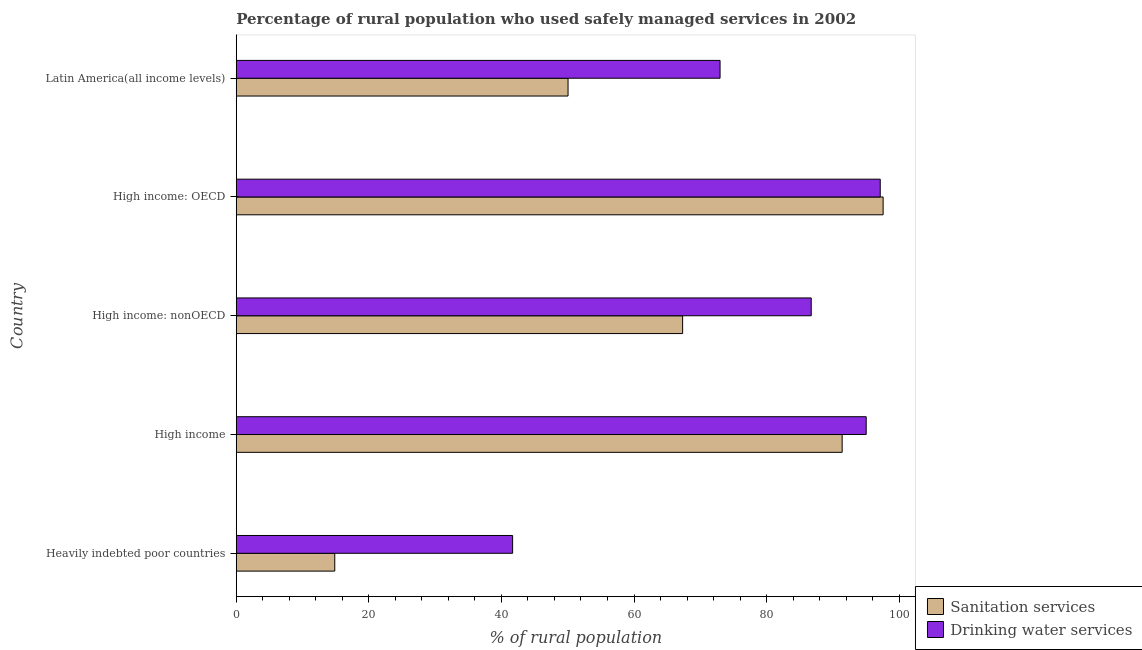How many different coloured bars are there?
Provide a short and direct response. 2. How many groups of bars are there?
Provide a succinct answer. 5. How many bars are there on the 5th tick from the top?
Your answer should be compact. 2. In how many cases, is the number of bars for a given country not equal to the number of legend labels?
Your response must be concise. 0. What is the percentage of rural population who used drinking water services in High income: nonOECD?
Your answer should be very brief. 86.73. Across all countries, what is the maximum percentage of rural population who used sanitation services?
Provide a short and direct response. 97.58. Across all countries, what is the minimum percentage of rural population who used drinking water services?
Provide a succinct answer. 41.69. In which country was the percentage of rural population who used drinking water services maximum?
Keep it short and to the point. High income: OECD. In which country was the percentage of rural population who used sanitation services minimum?
Your response must be concise. Heavily indebted poor countries. What is the total percentage of rural population who used sanitation services in the graph?
Provide a short and direct response. 321.23. What is the difference between the percentage of rural population who used drinking water services in High income and that in High income: OECD?
Provide a succinct answer. -2.12. What is the difference between the percentage of rural population who used sanitation services in High income and the percentage of rural population who used drinking water services in Latin America(all income levels)?
Keep it short and to the point. 18.42. What is the average percentage of rural population who used drinking water services per country?
Offer a very short reply. 78.72. What is the difference between the percentage of rural population who used drinking water services and percentage of rural population who used sanitation services in Heavily indebted poor countries?
Make the answer very short. 26.83. What is the ratio of the percentage of rural population who used drinking water services in High income: OECD to that in Latin America(all income levels)?
Your response must be concise. 1.33. What is the difference between the highest and the second highest percentage of rural population who used drinking water services?
Your response must be concise. 2.12. What is the difference between the highest and the lowest percentage of rural population who used drinking water services?
Keep it short and to the point. 55.45. What does the 2nd bar from the top in High income: nonOECD represents?
Offer a terse response. Sanitation services. What does the 2nd bar from the bottom in High income represents?
Your response must be concise. Drinking water services. How many bars are there?
Offer a very short reply. 10. Are all the bars in the graph horizontal?
Make the answer very short. Yes. What is the difference between two consecutive major ticks on the X-axis?
Offer a terse response. 20. Does the graph contain grids?
Offer a terse response. No. Where does the legend appear in the graph?
Your answer should be compact. Bottom right. How are the legend labels stacked?
Offer a very short reply. Vertical. What is the title of the graph?
Provide a short and direct response. Percentage of rural population who used safely managed services in 2002. What is the label or title of the X-axis?
Keep it short and to the point. % of rural population. What is the label or title of the Y-axis?
Provide a succinct answer. Country. What is the % of rural population of Sanitation services in Heavily indebted poor countries?
Offer a terse response. 14.86. What is the % of rural population of Drinking water services in Heavily indebted poor countries?
Your answer should be compact. 41.69. What is the % of rural population in Sanitation services in High income?
Provide a succinct answer. 91.4. What is the % of rural population of Drinking water services in High income?
Your answer should be very brief. 95.03. What is the % of rural population in Sanitation services in High income: nonOECD?
Provide a succinct answer. 67.34. What is the % of rural population in Drinking water services in High income: nonOECD?
Ensure brevity in your answer.  86.73. What is the % of rural population in Sanitation services in High income: OECD?
Your answer should be very brief. 97.58. What is the % of rural population in Drinking water services in High income: OECD?
Offer a very short reply. 97.15. What is the % of rural population in Sanitation services in Latin America(all income levels)?
Your answer should be compact. 50.05. What is the % of rural population of Drinking water services in Latin America(all income levels)?
Your response must be concise. 72.98. Across all countries, what is the maximum % of rural population of Sanitation services?
Offer a very short reply. 97.58. Across all countries, what is the maximum % of rural population in Drinking water services?
Make the answer very short. 97.15. Across all countries, what is the minimum % of rural population in Sanitation services?
Provide a succinct answer. 14.86. Across all countries, what is the minimum % of rural population in Drinking water services?
Keep it short and to the point. 41.69. What is the total % of rural population in Sanitation services in the graph?
Provide a succinct answer. 321.23. What is the total % of rural population of Drinking water services in the graph?
Offer a very short reply. 393.58. What is the difference between the % of rural population in Sanitation services in Heavily indebted poor countries and that in High income?
Give a very brief answer. -76.54. What is the difference between the % of rural population in Drinking water services in Heavily indebted poor countries and that in High income?
Offer a terse response. -53.34. What is the difference between the % of rural population in Sanitation services in Heavily indebted poor countries and that in High income: nonOECD?
Your response must be concise. -52.48. What is the difference between the % of rural population of Drinking water services in Heavily indebted poor countries and that in High income: nonOECD?
Give a very brief answer. -45.04. What is the difference between the % of rural population of Sanitation services in Heavily indebted poor countries and that in High income: OECD?
Offer a very short reply. -82.72. What is the difference between the % of rural population of Drinking water services in Heavily indebted poor countries and that in High income: OECD?
Give a very brief answer. -55.45. What is the difference between the % of rural population of Sanitation services in Heavily indebted poor countries and that in Latin America(all income levels)?
Make the answer very short. -35.19. What is the difference between the % of rural population in Drinking water services in Heavily indebted poor countries and that in Latin America(all income levels)?
Your response must be concise. -31.29. What is the difference between the % of rural population of Sanitation services in High income and that in High income: nonOECD?
Your answer should be very brief. 24.07. What is the difference between the % of rural population of Drinking water services in High income and that in High income: nonOECD?
Give a very brief answer. 8.29. What is the difference between the % of rural population of Sanitation services in High income and that in High income: OECD?
Offer a very short reply. -6.18. What is the difference between the % of rural population of Drinking water services in High income and that in High income: OECD?
Offer a terse response. -2.12. What is the difference between the % of rural population of Sanitation services in High income and that in Latin America(all income levels)?
Your answer should be very brief. 41.35. What is the difference between the % of rural population of Drinking water services in High income and that in Latin America(all income levels)?
Your answer should be compact. 22.05. What is the difference between the % of rural population in Sanitation services in High income: nonOECD and that in High income: OECD?
Offer a terse response. -30.24. What is the difference between the % of rural population in Drinking water services in High income: nonOECD and that in High income: OECD?
Your answer should be compact. -10.41. What is the difference between the % of rural population in Sanitation services in High income: nonOECD and that in Latin America(all income levels)?
Ensure brevity in your answer.  17.29. What is the difference between the % of rural population of Drinking water services in High income: nonOECD and that in Latin America(all income levels)?
Offer a very short reply. 13.75. What is the difference between the % of rural population in Sanitation services in High income: OECD and that in Latin America(all income levels)?
Offer a very short reply. 47.53. What is the difference between the % of rural population of Drinking water services in High income: OECD and that in Latin America(all income levels)?
Provide a short and direct response. 24.16. What is the difference between the % of rural population in Sanitation services in Heavily indebted poor countries and the % of rural population in Drinking water services in High income?
Offer a terse response. -80.17. What is the difference between the % of rural population in Sanitation services in Heavily indebted poor countries and the % of rural population in Drinking water services in High income: nonOECD?
Your answer should be very brief. -71.87. What is the difference between the % of rural population in Sanitation services in Heavily indebted poor countries and the % of rural population in Drinking water services in High income: OECD?
Keep it short and to the point. -82.28. What is the difference between the % of rural population in Sanitation services in Heavily indebted poor countries and the % of rural population in Drinking water services in Latin America(all income levels)?
Your answer should be compact. -58.12. What is the difference between the % of rural population in Sanitation services in High income and the % of rural population in Drinking water services in High income: nonOECD?
Provide a short and direct response. 4.67. What is the difference between the % of rural population in Sanitation services in High income and the % of rural population in Drinking water services in High income: OECD?
Your answer should be compact. -5.74. What is the difference between the % of rural population of Sanitation services in High income and the % of rural population of Drinking water services in Latin America(all income levels)?
Your answer should be very brief. 18.42. What is the difference between the % of rural population of Sanitation services in High income: nonOECD and the % of rural population of Drinking water services in High income: OECD?
Ensure brevity in your answer.  -29.81. What is the difference between the % of rural population of Sanitation services in High income: nonOECD and the % of rural population of Drinking water services in Latin America(all income levels)?
Provide a short and direct response. -5.65. What is the difference between the % of rural population in Sanitation services in High income: OECD and the % of rural population in Drinking water services in Latin America(all income levels)?
Make the answer very short. 24.6. What is the average % of rural population in Sanitation services per country?
Ensure brevity in your answer.  64.25. What is the average % of rural population of Drinking water services per country?
Give a very brief answer. 78.72. What is the difference between the % of rural population in Sanitation services and % of rural population in Drinking water services in Heavily indebted poor countries?
Offer a very short reply. -26.83. What is the difference between the % of rural population of Sanitation services and % of rural population of Drinking water services in High income?
Provide a short and direct response. -3.63. What is the difference between the % of rural population in Sanitation services and % of rural population in Drinking water services in High income: nonOECD?
Keep it short and to the point. -19.4. What is the difference between the % of rural population in Sanitation services and % of rural population in Drinking water services in High income: OECD?
Your answer should be compact. 0.43. What is the difference between the % of rural population in Sanitation services and % of rural population in Drinking water services in Latin America(all income levels)?
Keep it short and to the point. -22.93. What is the ratio of the % of rural population in Sanitation services in Heavily indebted poor countries to that in High income?
Ensure brevity in your answer.  0.16. What is the ratio of the % of rural population of Drinking water services in Heavily indebted poor countries to that in High income?
Offer a very short reply. 0.44. What is the ratio of the % of rural population in Sanitation services in Heavily indebted poor countries to that in High income: nonOECD?
Offer a very short reply. 0.22. What is the ratio of the % of rural population of Drinking water services in Heavily indebted poor countries to that in High income: nonOECD?
Offer a very short reply. 0.48. What is the ratio of the % of rural population of Sanitation services in Heavily indebted poor countries to that in High income: OECD?
Offer a very short reply. 0.15. What is the ratio of the % of rural population of Drinking water services in Heavily indebted poor countries to that in High income: OECD?
Offer a terse response. 0.43. What is the ratio of the % of rural population in Sanitation services in Heavily indebted poor countries to that in Latin America(all income levels)?
Make the answer very short. 0.3. What is the ratio of the % of rural population in Drinking water services in Heavily indebted poor countries to that in Latin America(all income levels)?
Your answer should be compact. 0.57. What is the ratio of the % of rural population of Sanitation services in High income to that in High income: nonOECD?
Offer a terse response. 1.36. What is the ratio of the % of rural population in Drinking water services in High income to that in High income: nonOECD?
Give a very brief answer. 1.1. What is the ratio of the % of rural population of Sanitation services in High income to that in High income: OECD?
Make the answer very short. 0.94. What is the ratio of the % of rural population of Drinking water services in High income to that in High income: OECD?
Offer a very short reply. 0.98. What is the ratio of the % of rural population of Sanitation services in High income to that in Latin America(all income levels)?
Your response must be concise. 1.83. What is the ratio of the % of rural population in Drinking water services in High income to that in Latin America(all income levels)?
Offer a terse response. 1.3. What is the ratio of the % of rural population of Sanitation services in High income: nonOECD to that in High income: OECD?
Your response must be concise. 0.69. What is the ratio of the % of rural population in Drinking water services in High income: nonOECD to that in High income: OECD?
Give a very brief answer. 0.89. What is the ratio of the % of rural population in Sanitation services in High income: nonOECD to that in Latin America(all income levels)?
Make the answer very short. 1.35. What is the ratio of the % of rural population of Drinking water services in High income: nonOECD to that in Latin America(all income levels)?
Make the answer very short. 1.19. What is the ratio of the % of rural population of Sanitation services in High income: OECD to that in Latin America(all income levels)?
Offer a very short reply. 1.95. What is the ratio of the % of rural population of Drinking water services in High income: OECD to that in Latin America(all income levels)?
Keep it short and to the point. 1.33. What is the difference between the highest and the second highest % of rural population in Sanitation services?
Your response must be concise. 6.18. What is the difference between the highest and the second highest % of rural population in Drinking water services?
Your response must be concise. 2.12. What is the difference between the highest and the lowest % of rural population in Sanitation services?
Your response must be concise. 82.72. What is the difference between the highest and the lowest % of rural population of Drinking water services?
Give a very brief answer. 55.45. 